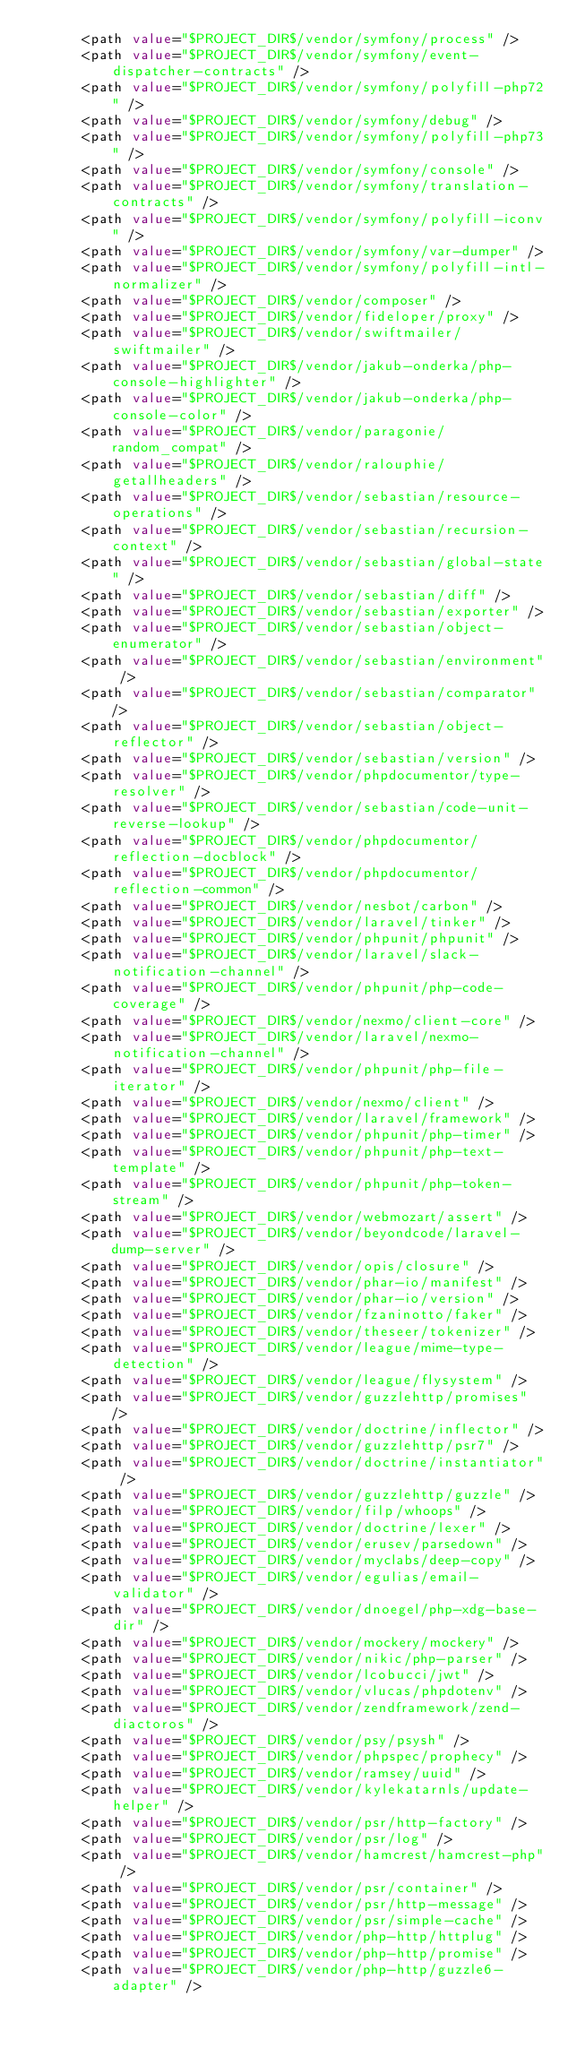Convert code to text. <code><loc_0><loc_0><loc_500><loc_500><_XML_>      <path value="$PROJECT_DIR$/vendor/symfony/process" />
      <path value="$PROJECT_DIR$/vendor/symfony/event-dispatcher-contracts" />
      <path value="$PROJECT_DIR$/vendor/symfony/polyfill-php72" />
      <path value="$PROJECT_DIR$/vendor/symfony/debug" />
      <path value="$PROJECT_DIR$/vendor/symfony/polyfill-php73" />
      <path value="$PROJECT_DIR$/vendor/symfony/console" />
      <path value="$PROJECT_DIR$/vendor/symfony/translation-contracts" />
      <path value="$PROJECT_DIR$/vendor/symfony/polyfill-iconv" />
      <path value="$PROJECT_DIR$/vendor/symfony/var-dumper" />
      <path value="$PROJECT_DIR$/vendor/symfony/polyfill-intl-normalizer" />
      <path value="$PROJECT_DIR$/vendor/composer" />
      <path value="$PROJECT_DIR$/vendor/fideloper/proxy" />
      <path value="$PROJECT_DIR$/vendor/swiftmailer/swiftmailer" />
      <path value="$PROJECT_DIR$/vendor/jakub-onderka/php-console-highlighter" />
      <path value="$PROJECT_DIR$/vendor/jakub-onderka/php-console-color" />
      <path value="$PROJECT_DIR$/vendor/paragonie/random_compat" />
      <path value="$PROJECT_DIR$/vendor/ralouphie/getallheaders" />
      <path value="$PROJECT_DIR$/vendor/sebastian/resource-operations" />
      <path value="$PROJECT_DIR$/vendor/sebastian/recursion-context" />
      <path value="$PROJECT_DIR$/vendor/sebastian/global-state" />
      <path value="$PROJECT_DIR$/vendor/sebastian/diff" />
      <path value="$PROJECT_DIR$/vendor/sebastian/exporter" />
      <path value="$PROJECT_DIR$/vendor/sebastian/object-enumerator" />
      <path value="$PROJECT_DIR$/vendor/sebastian/environment" />
      <path value="$PROJECT_DIR$/vendor/sebastian/comparator" />
      <path value="$PROJECT_DIR$/vendor/sebastian/object-reflector" />
      <path value="$PROJECT_DIR$/vendor/sebastian/version" />
      <path value="$PROJECT_DIR$/vendor/phpdocumentor/type-resolver" />
      <path value="$PROJECT_DIR$/vendor/sebastian/code-unit-reverse-lookup" />
      <path value="$PROJECT_DIR$/vendor/phpdocumentor/reflection-docblock" />
      <path value="$PROJECT_DIR$/vendor/phpdocumentor/reflection-common" />
      <path value="$PROJECT_DIR$/vendor/nesbot/carbon" />
      <path value="$PROJECT_DIR$/vendor/laravel/tinker" />
      <path value="$PROJECT_DIR$/vendor/phpunit/phpunit" />
      <path value="$PROJECT_DIR$/vendor/laravel/slack-notification-channel" />
      <path value="$PROJECT_DIR$/vendor/phpunit/php-code-coverage" />
      <path value="$PROJECT_DIR$/vendor/nexmo/client-core" />
      <path value="$PROJECT_DIR$/vendor/laravel/nexmo-notification-channel" />
      <path value="$PROJECT_DIR$/vendor/phpunit/php-file-iterator" />
      <path value="$PROJECT_DIR$/vendor/nexmo/client" />
      <path value="$PROJECT_DIR$/vendor/laravel/framework" />
      <path value="$PROJECT_DIR$/vendor/phpunit/php-timer" />
      <path value="$PROJECT_DIR$/vendor/phpunit/php-text-template" />
      <path value="$PROJECT_DIR$/vendor/phpunit/php-token-stream" />
      <path value="$PROJECT_DIR$/vendor/webmozart/assert" />
      <path value="$PROJECT_DIR$/vendor/beyondcode/laravel-dump-server" />
      <path value="$PROJECT_DIR$/vendor/opis/closure" />
      <path value="$PROJECT_DIR$/vendor/phar-io/manifest" />
      <path value="$PROJECT_DIR$/vendor/phar-io/version" />
      <path value="$PROJECT_DIR$/vendor/fzaninotto/faker" />
      <path value="$PROJECT_DIR$/vendor/theseer/tokenizer" />
      <path value="$PROJECT_DIR$/vendor/league/mime-type-detection" />
      <path value="$PROJECT_DIR$/vendor/league/flysystem" />
      <path value="$PROJECT_DIR$/vendor/guzzlehttp/promises" />
      <path value="$PROJECT_DIR$/vendor/doctrine/inflector" />
      <path value="$PROJECT_DIR$/vendor/guzzlehttp/psr7" />
      <path value="$PROJECT_DIR$/vendor/doctrine/instantiator" />
      <path value="$PROJECT_DIR$/vendor/guzzlehttp/guzzle" />
      <path value="$PROJECT_DIR$/vendor/filp/whoops" />
      <path value="$PROJECT_DIR$/vendor/doctrine/lexer" />
      <path value="$PROJECT_DIR$/vendor/erusev/parsedown" />
      <path value="$PROJECT_DIR$/vendor/myclabs/deep-copy" />
      <path value="$PROJECT_DIR$/vendor/egulias/email-validator" />
      <path value="$PROJECT_DIR$/vendor/dnoegel/php-xdg-base-dir" />
      <path value="$PROJECT_DIR$/vendor/mockery/mockery" />
      <path value="$PROJECT_DIR$/vendor/nikic/php-parser" />
      <path value="$PROJECT_DIR$/vendor/lcobucci/jwt" />
      <path value="$PROJECT_DIR$/vendor/vlucas/phpdotenv" />
      <path value="$PROJECT_DIR$/vendor/zendframework/zend-diactoros" />
      <path value="$PROJECT_DIR$/vendor/psy/psysh" />
      <path value="$PROJECT_DIR$/vendor/phpspec/prophecy" />
      <path value="$PROJECT_DIR$/vendor/ramsey/uuid" />
      <path value="$PROJECT_DIR$/vendor/kylekatarnls/update-helper" />
      <path value="$PROJECT_DIR$/vendor/psr/http-factory" />
      <path value="$PROJECT_DIR$/vendor/psr/log" />
      <path value="$PROJECT_DIR$/vendor/hamcrest/hamcrest-php" />
      <path value="$PROJECT_DIR$/vendor/psr/container" />
      <path value="$PROJECT_DIR$/vendor/psr/http-message" />
      <path value="$PROJECT_DIR$/vendor/psr/simple-cache" />
      <path value="$PROJECT_DIR$/vendor/php-http/httplug" />
      <path value="$PROJECT_DIR$/vendor/php-http/promise" />
      <path value="$PROJECT_DIR$/vendor/php-http/guzzle6-adapter" /></code> 